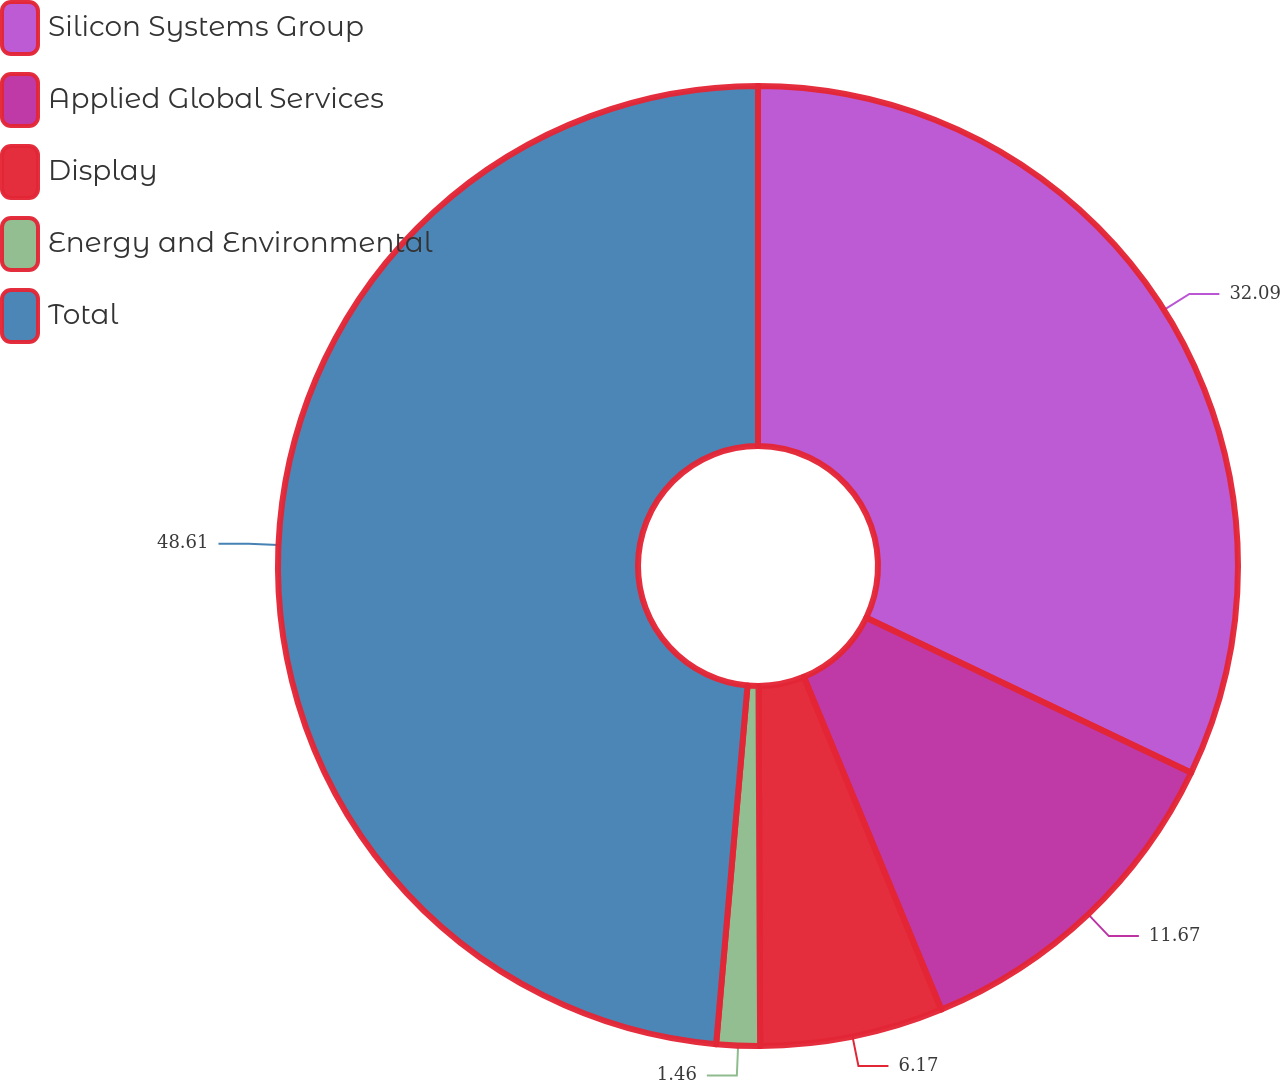<chart> <loc_0><loc_0><loc_500><loc_500><pie_chart><fcel>Silicon Systems Group<fcel>Applied Global Services<fcel>Display<fcel>Energy and Environmental<fcel>Total<nl><fcel>32.09%<fcel>11.67%<fcel>6.17%<fcel>1.46%<fcel>48.61%<nl></chart> 